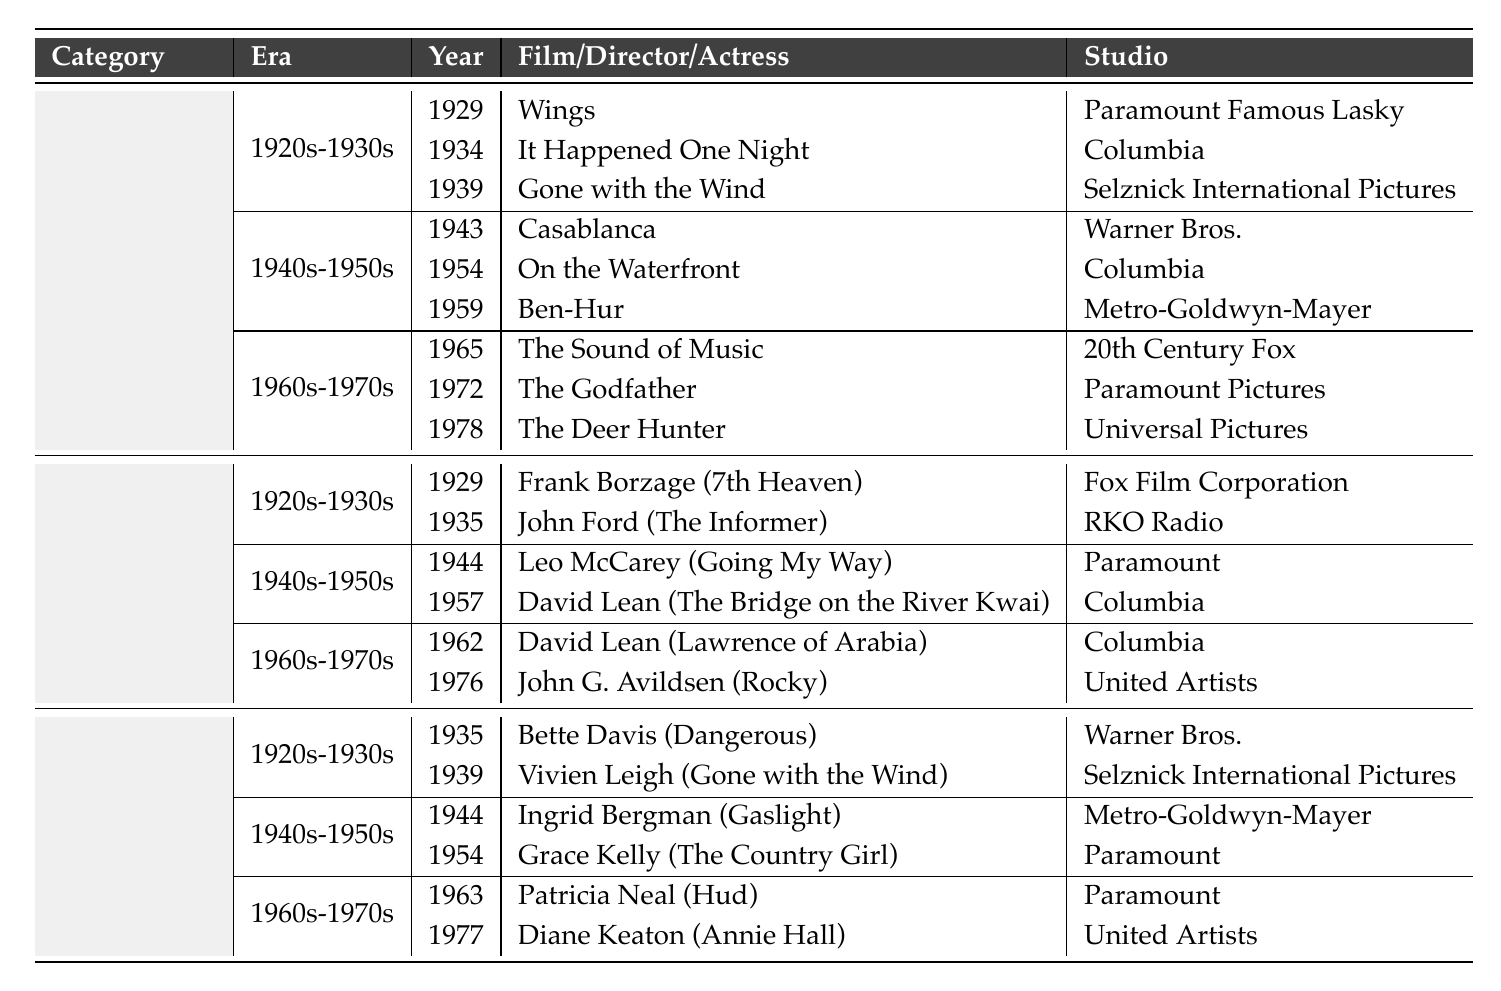What was the first film to win the Best Picture Oscar? The table shows the year 1929 under the Best Picture category, with the film "Wings" listed. Therefore, "Wings" is the first film to win the Best Picture Oscar.
Answer: Wings Which studio produced "Gone with the Wind"? In the table, "Gone with the Wind" is listed under the Best Picture category for the year 1939, and it indicates that it was produced by Selznick International Pictures.
Answer: Selznick International Pictures How many films won the Best Director Oscar in the 1940s-1950s? In the table under the Best Director category, there are two entries for the era 1940s-1950s (1944 and 1957). Hence, two films won the Best Director Oscar during that time period.
Answer: 2 Which film won the Best Actress Oscar in 1963? The table indicates for the Best Actress category in 1963 a film is listed as "Hud" with Patricia Neal as the actress. Therefore, "Hud" won the Best Actress Oscar that year.
Answer: Hud Is "The Godfather" the only Best Picture nominee from the 1970s listed? The table mentions that "The Godfather" won the Best Picture in 1972, but it lists other films from other eras. However, it does not list any other films from the 1970s. Therefore, "The Godfather" is the only one listed for that category.
Answer: Yes Which director won the Best Director Oscar for a film released in 1957? In the Best Director category, the year 1957 corresponds to the film "The Bridge on the River Kwai," directed by David Lean. Thus, David Lean won the Oscar for that film.
Answer: David Lean What is the difference in years between the first Best Picture winner and the last Best Picture winner listed in the table? The first Best Picture winner listed is from 1929 and the last from 1978, so the difference is 1978 - 1929 = 49 years.
Answer: 49 years Which studio received the most Best Picture Oscars in the 1920s-1930s? The table lists three films from the 1920s-1930s for Best Picture: "Wings" from Paramount, "It Happened One Night" from Columbia, and "Gone with the Wind" from Selznick International Pictures. Each studio won one Oscar, so there is a tie overall.
Answer: Tie How many actresses won the Best Actress Oscar for films produced by Paramount in the 1960s-1970s? The table shows two winners from the Best Actress category in the 1960s-1970s: "Patricia Neal" for "Hud" in 1963 and "Diane Keaton" for "Annie Hall" in 1977. Both films were produced by Paramount, therefore two actresses won this award from Paramount during that era.
Answer: 2 